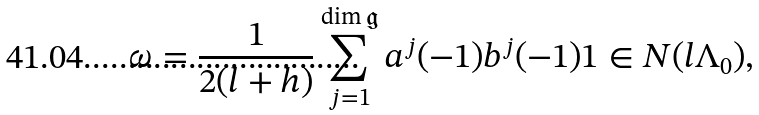Convert formula to latex. <formula><loc_0><loc_0><loc_500><loc_500>\omega = \frac { 1 } { 2 ( l + h ) } \sum _ { j = 1 } ^ { \dim \mathfrak { g } } a ^ { j } ( - 1 ) b ^ { j } ( - 1 ) 1 \in N ( l \Lambda _ { 0 } ) ,</formula> 